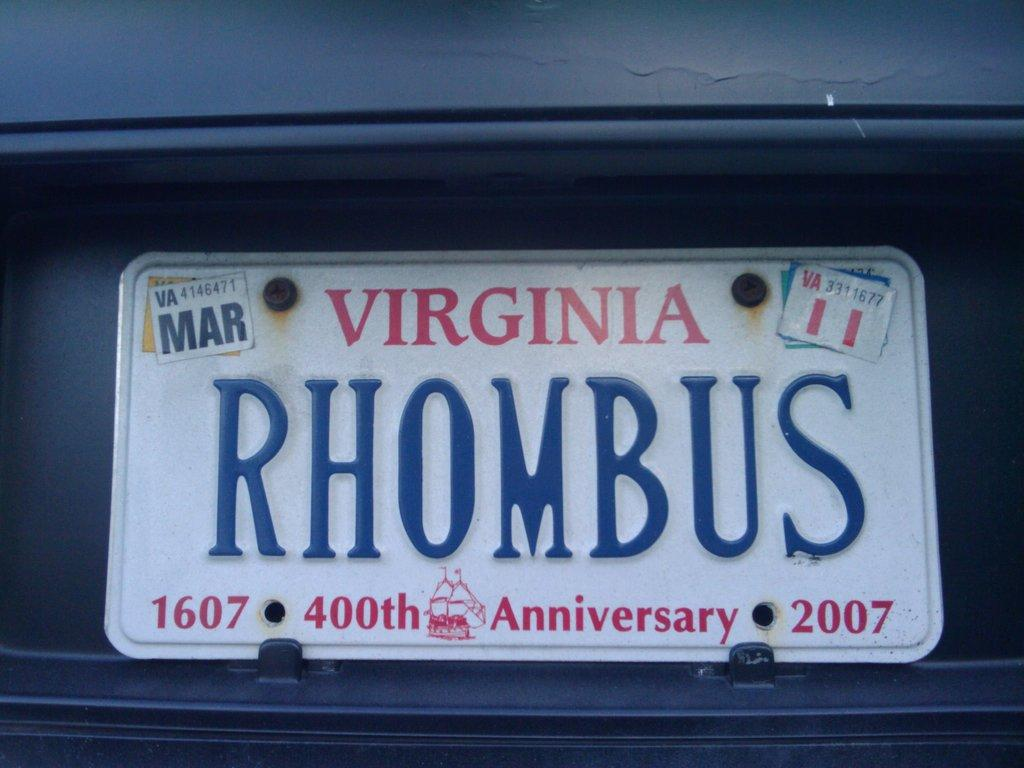<image>
Provide a brief description of the given image. A Virginia license plate on a car with the letters RHOMBUS. 